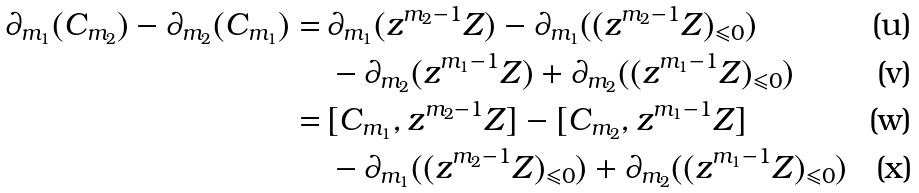Convert formula to latex. <formula><loc_0><loc_0><loc_500><loc_500>\partial _ { m _ { 1 } } ( C _ { m _ { 2 } } ) - \partial _ { m _ { 2 } } ( C _ { m _ { 1 } } ) = & \, \partial _ { m _ { 1 } } ( z ^ { m _ { 2 } - 1 } Z ) - \partial _ { m _ { 1 } } ( ( z ^ { m _ { 2 } - 1 } Z ) _ { \leqslant 0 } ) \\ & \, - \partial _ { m _ { 2 } } ( z ^ { m _ { 1 } - 1 } Z ) + \partial _ { m _ { 2 } } ( ( z ^ { m _ { 1 } - 1 } Z ) _ { \leqslant 0 } ) \\ = & \, [ C _ { m _ { 1 } } , z ^ { m _ { 2 } - 1 } Z ] - [ C _ { m _ { 2 } } , z ^ { m _ { 1 } - 1 } Z ] \\ & \, - \partial _ { m _ { 1 } } ( ( z ^ { m _ { 2 } - 1 } Z ) _ { \leqslant 0 } ) + \partial _ { m _ { 2 } } ( ( z ^ { m _ { 1 } - 1 } Z ) _ { \leqslant 0 } )</formula> 